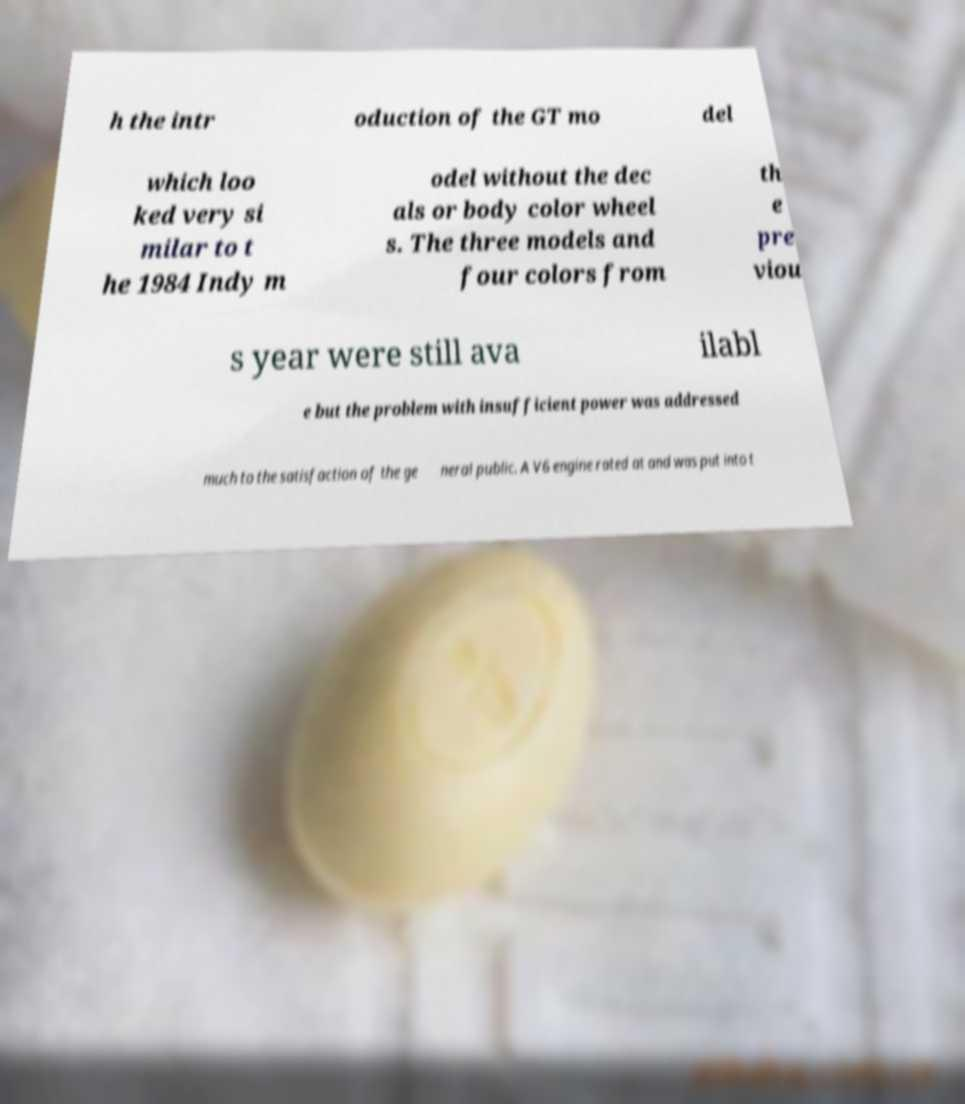Please identify and transcribe the text found in this image. h the intr oduction of the GT mo del which loo ked very si milar to t he 1984 Indy m odel without the dec als or body color wheel s. The three models and four colors from th e pre viou s year were still ava ilabl e but the problem with insufficient power was addressed much to the satisfaction of the ge neral public. A V6 engine rated at and was put into t 